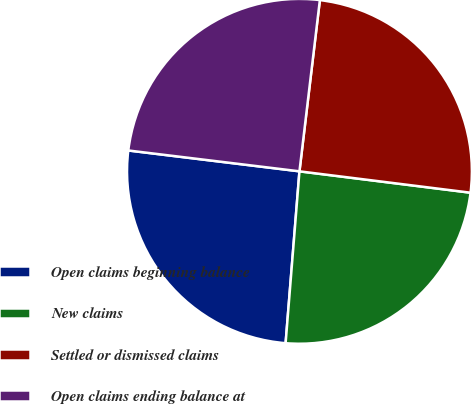<chart> <loc_0><loc_0><loc_500><loc_500><pie_chart><fcel>Open claims beginning balance<fcel>New claims<fcel>Settled or dismissed claims<fcel>Open claims ending balance at<nl><fcel>25.65%<fcel>24.3%<fcel>25.09%<fcel>24.96%<nl></chart> 